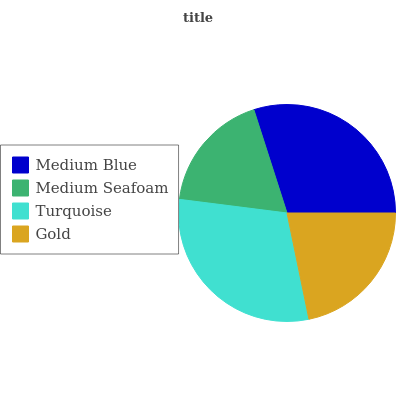Is Medium Seafoam the minimum?
Answer yes or no. Yes. Is Turquoise the maximum?
Answer yes or no. Yes. Is Turquoise the minimum?
Answer yes or no. No. Is Medium Seafoam the maximum?
Answer yes or no. No. Is Turquoise greater than Medium Seafoam?
Answer yes or no. Yes. Is Medium Seafoam less than Turquoise?
Answer yes or no. Yes. Is Medium Seafoam greater than Turquoise?
Answer yes or no. No. Is Turquoise less than Medium Seafoam?
Answer yes or no. No. Is Medium Blue the high median?
Answer yes or no. Yes. Is Gold the low median?
Answer yes or no. Yes. Is Gold the high median?
Answer yes or no. No. Is Turquoise the low median?
Answer yes or no. No. 